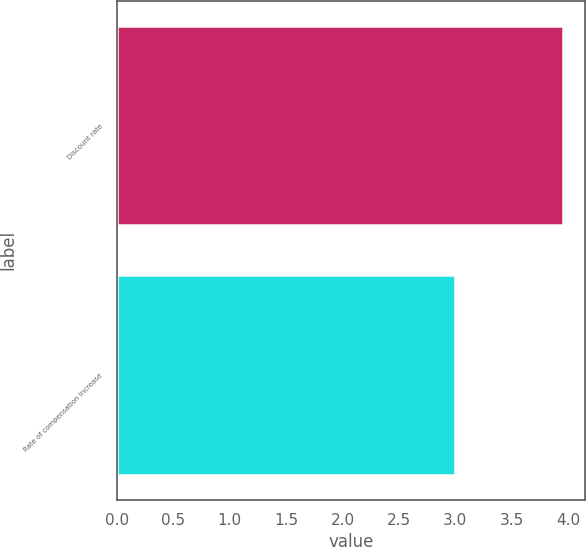Convert chart to OTSL. <chart><loc_0><loc_0><loc_500><loc_500><bar_chart><fcel>Discount rate<fcel>Rate of compensation increase<nl><fcel>3.95<fcel>3<nl></chart> 